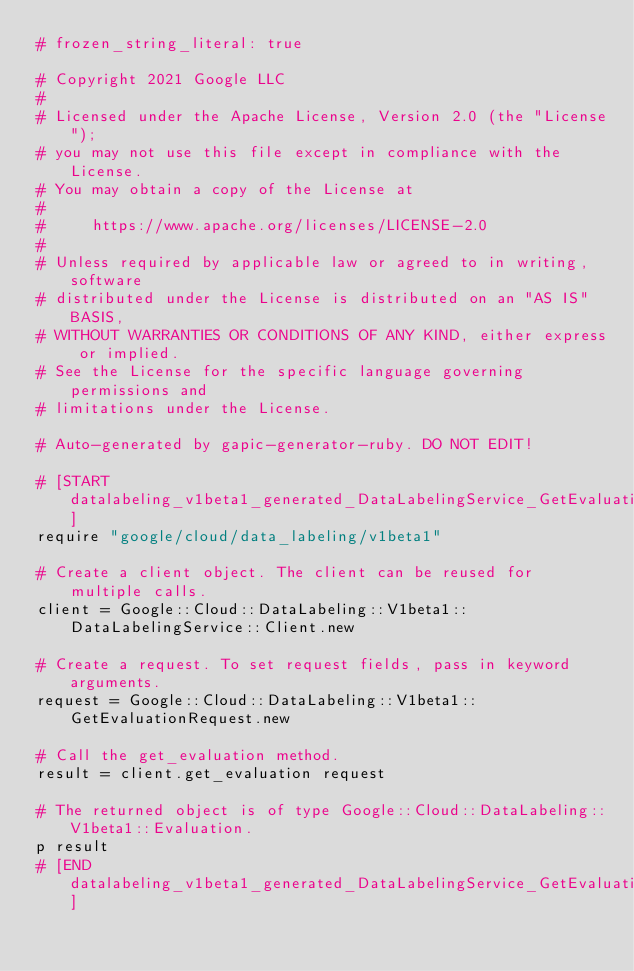<code> <loc_0><loc_0><loc_500><loc_500><_Ruby_># frozen_string_literal: true

# Copyright 2021 Google LLC
#
# Licensed under the Apache License, Version 2.0 (the "License");
# you may not use this file except in compliance with the License.
# You may obtain a copy of the License at
#
#     https://www.apache.org/licenses/LICENSE-2.0
#
# Unless required by applicable law or agreed to in writing, software
# distributed under the License is distributed on an "AS IS" BASIS,
# WITHOUT WARRANTIES OR CONDITIONS OF ANY KIND, either express or implied.
# See the License for the specific language governing permissions and
# limitations under the License.

# Auto-generated by gapic-generator-ruby. DO NOT EDIT!

# [START datalabeling_v1beta1_generated_DataLabelingService_GetEvaluation_sync]
require "google/cloud/data_labeling/v1beta1"

# Create a client object. The client can be reused for multiple calls.
client = Google::Cloud::DataLabeling::V1beta1::DataLabelingService::Client.new

# Create a request. To set request fields, pass in keyword arguments.
request = Google::Cloud::DataLabeling::V1beta1::GetEvaluationRequest.new

# Call the get_evaluation method.
result = client.get_evaluation request

# The returned object is of type Google::Cloud::DataLabeling::V1beta1::Evaluation.
p result
# [END datalabeling_v1beta1_generated_DataLabelingService_GetEvaluation_sync]
</code> 